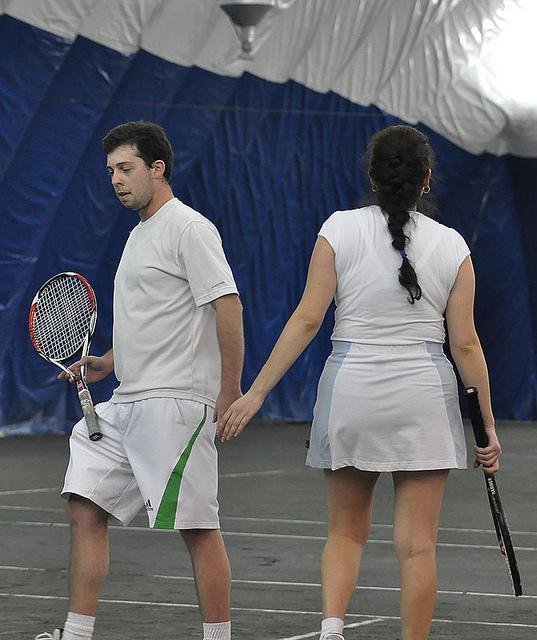How many men in the picture?
Give a very brief answer. 1. How many tennis rackets are in the picture?
Give a very brief answer. 2. How many people are there?
Give a very brief answer. 2. 